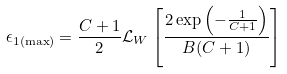<formula> <loc_0><loc_0><loc_500><loc_500>\epsilon _ { 1 ( \max ) } = \frac { C + 1 } 2 { \mathcal { L } } _ { W } \left [ \frac { 2 \exp \left ( - \frac { 1 } { C + 1 } \right ) } { B ( C + 1 ) } \right ]</formula> 